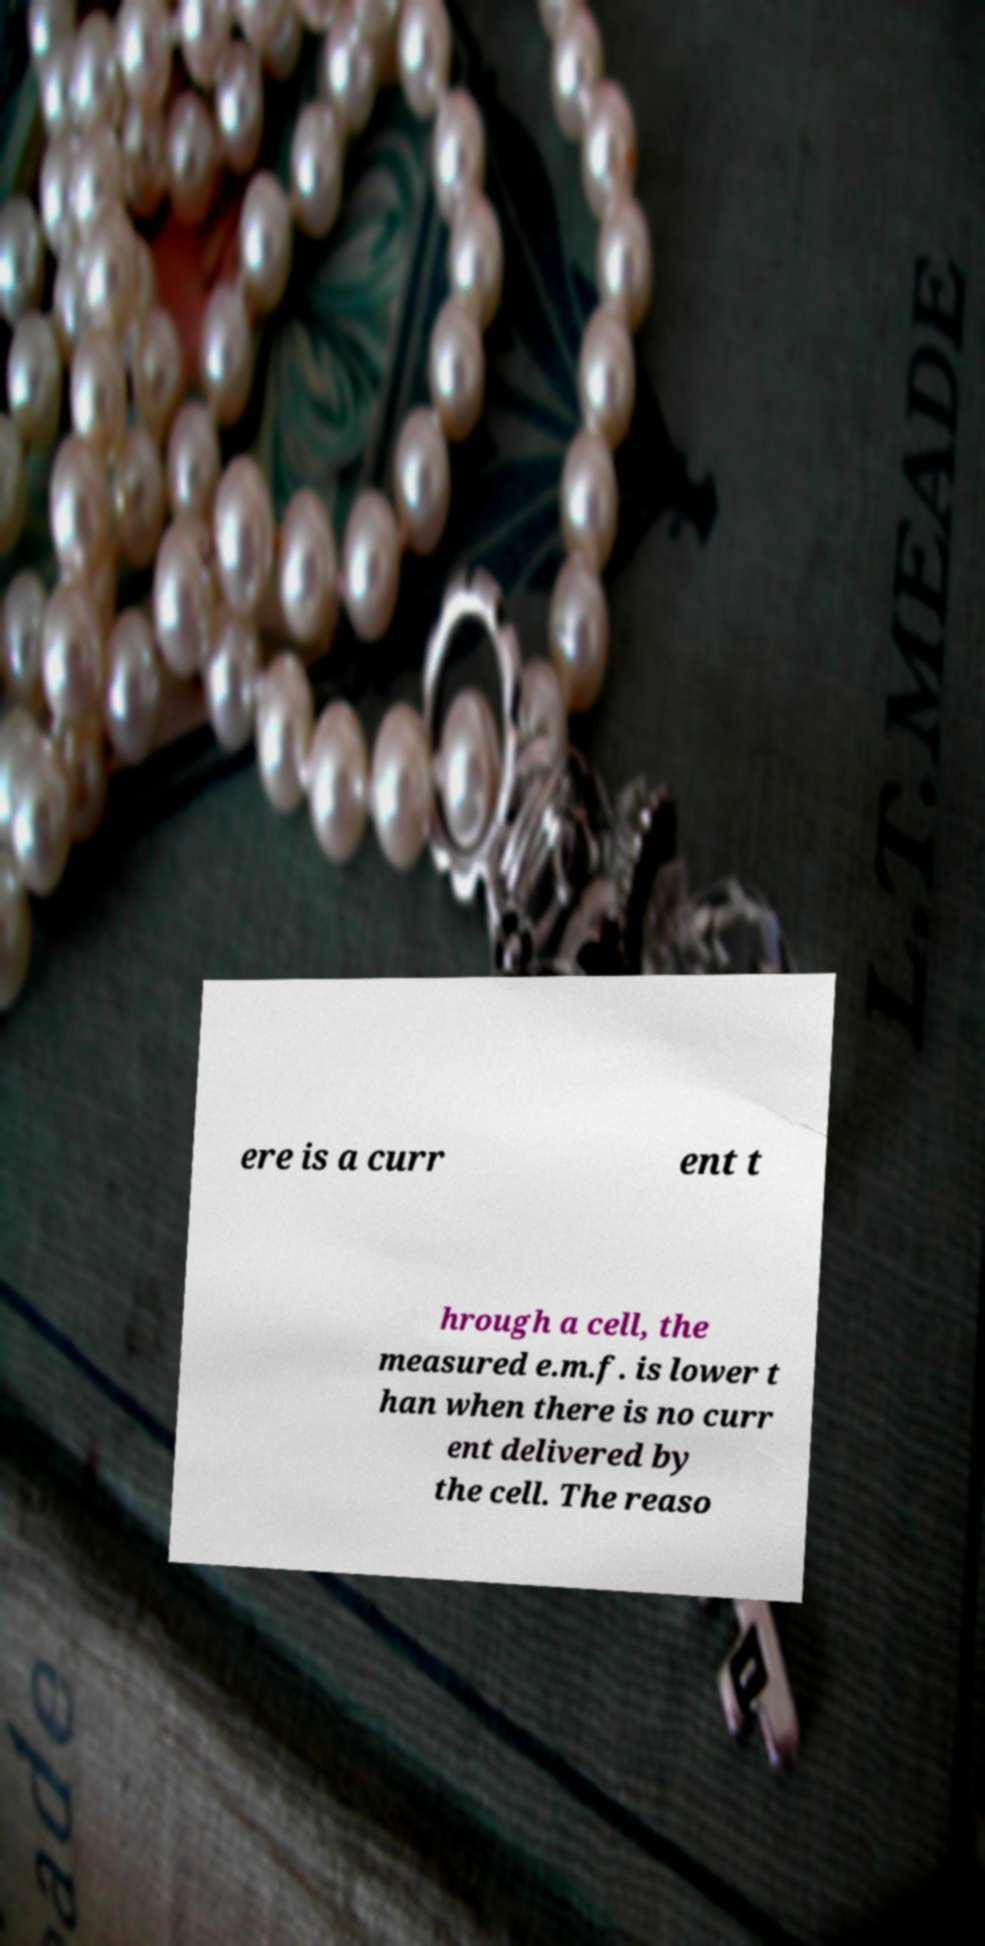Can you read and provide the text displayed in the image?This photo seems to have some interesting text. Can you extract and type it out for me? ere is a curr ent t hrough a cell, the measured e.m.f. is lower t han when there is no curr ent delivered by the cell. The reaso 